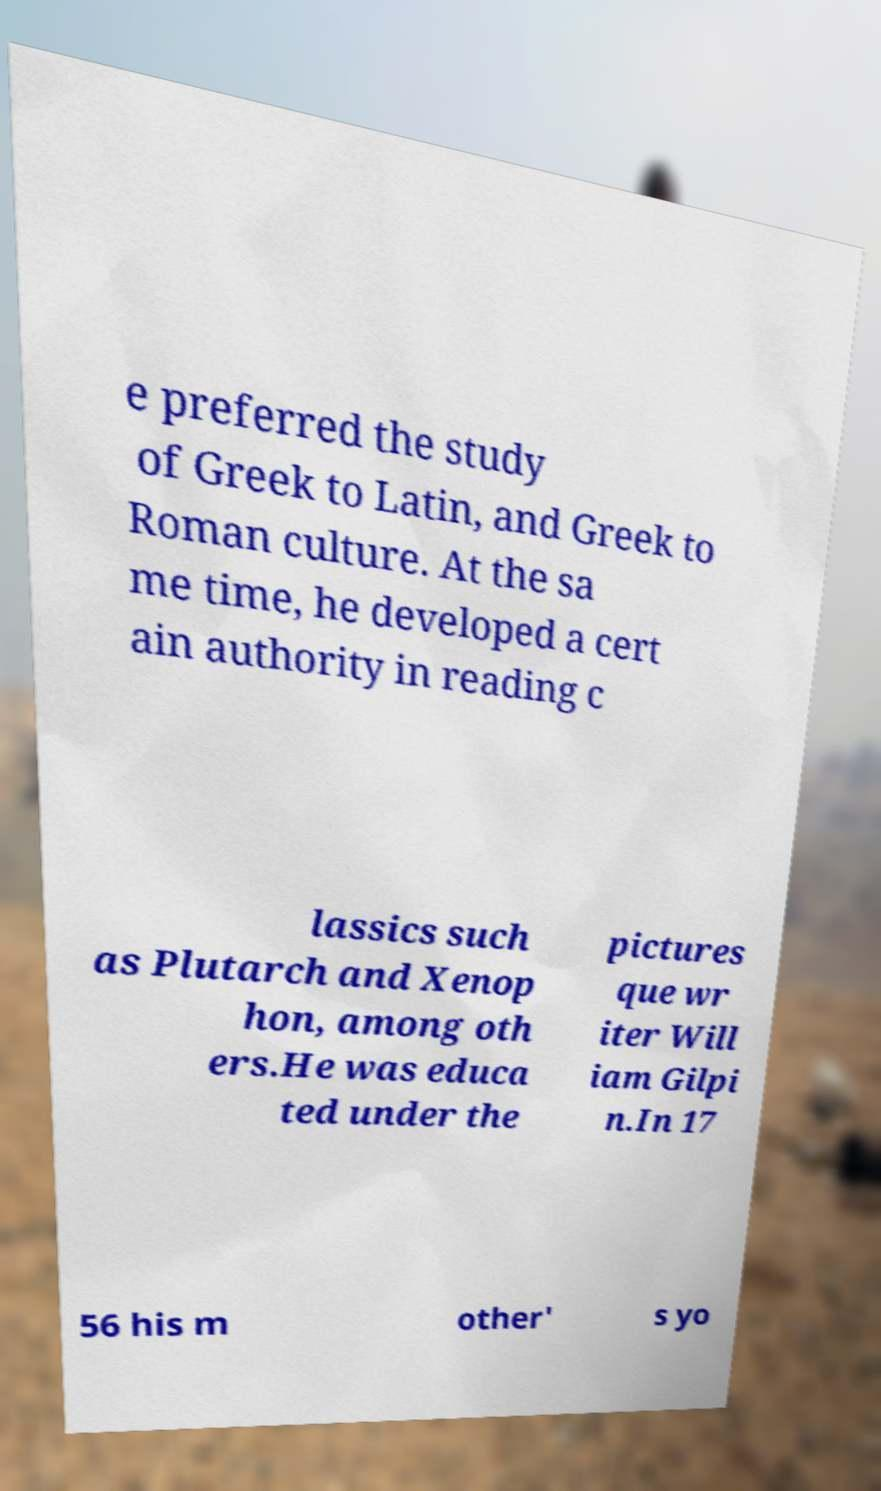What messages or text are displayed in this image? I need them in a readable, typed format. e preferred the study of Greek to Latin, and Greek to Roman culture. At the sa me time, he developed a cert ain authority in reading c lassics such as Plutarch and Xenop hon, among oth ers.He was educa ted under the pictures que wr iter Will iam Gilpi n.In 17 56 his m other' s yo 